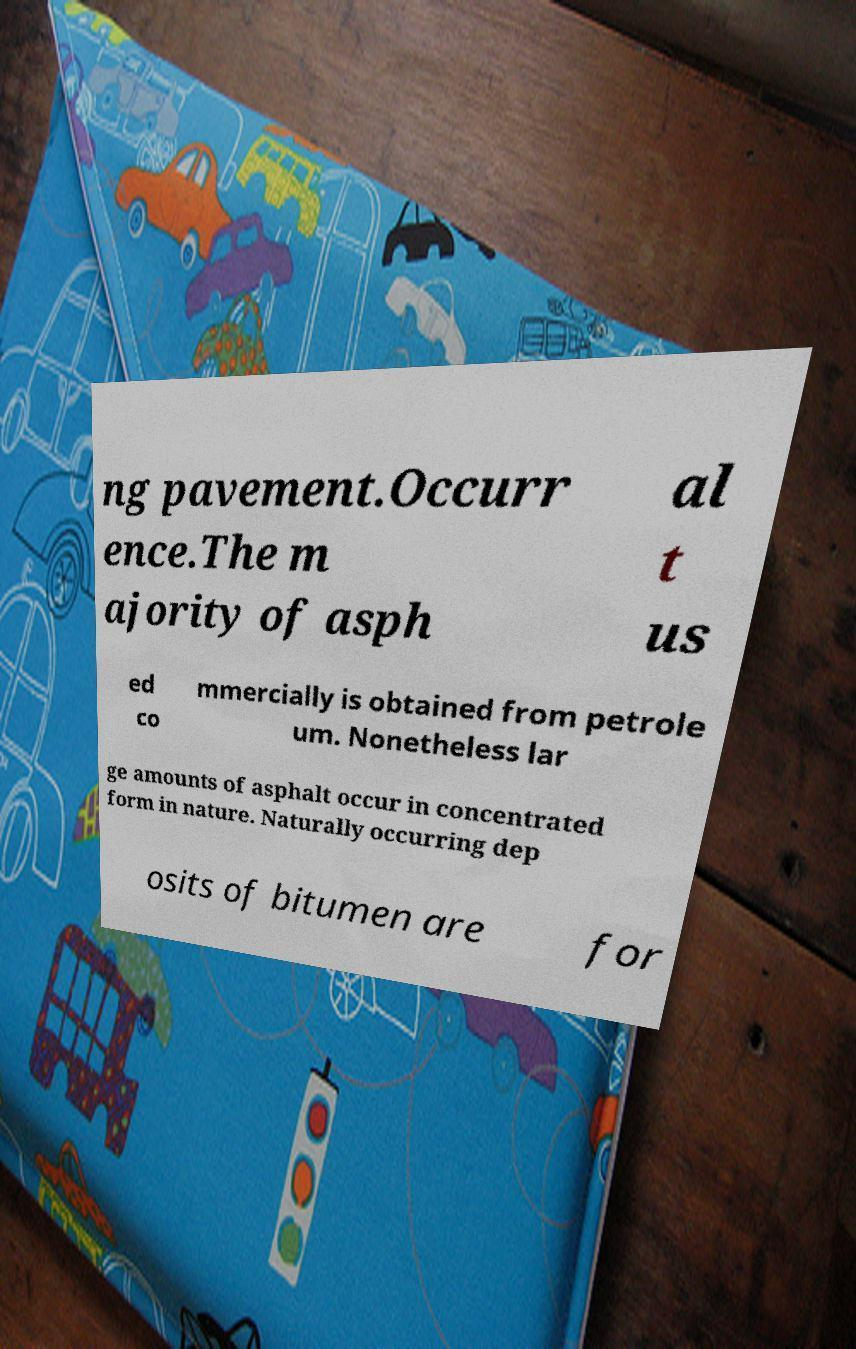Can you accurately transcribe the text from the provided image for me? ng pavement.Occurr ence.The m ajority of asph al t us ed co mmercially is obtained from petrole um. Nonetheless lar ge amounts of asphalt occur in concentrated form in nature. Naturally occurring dep osits of bitumen are for 